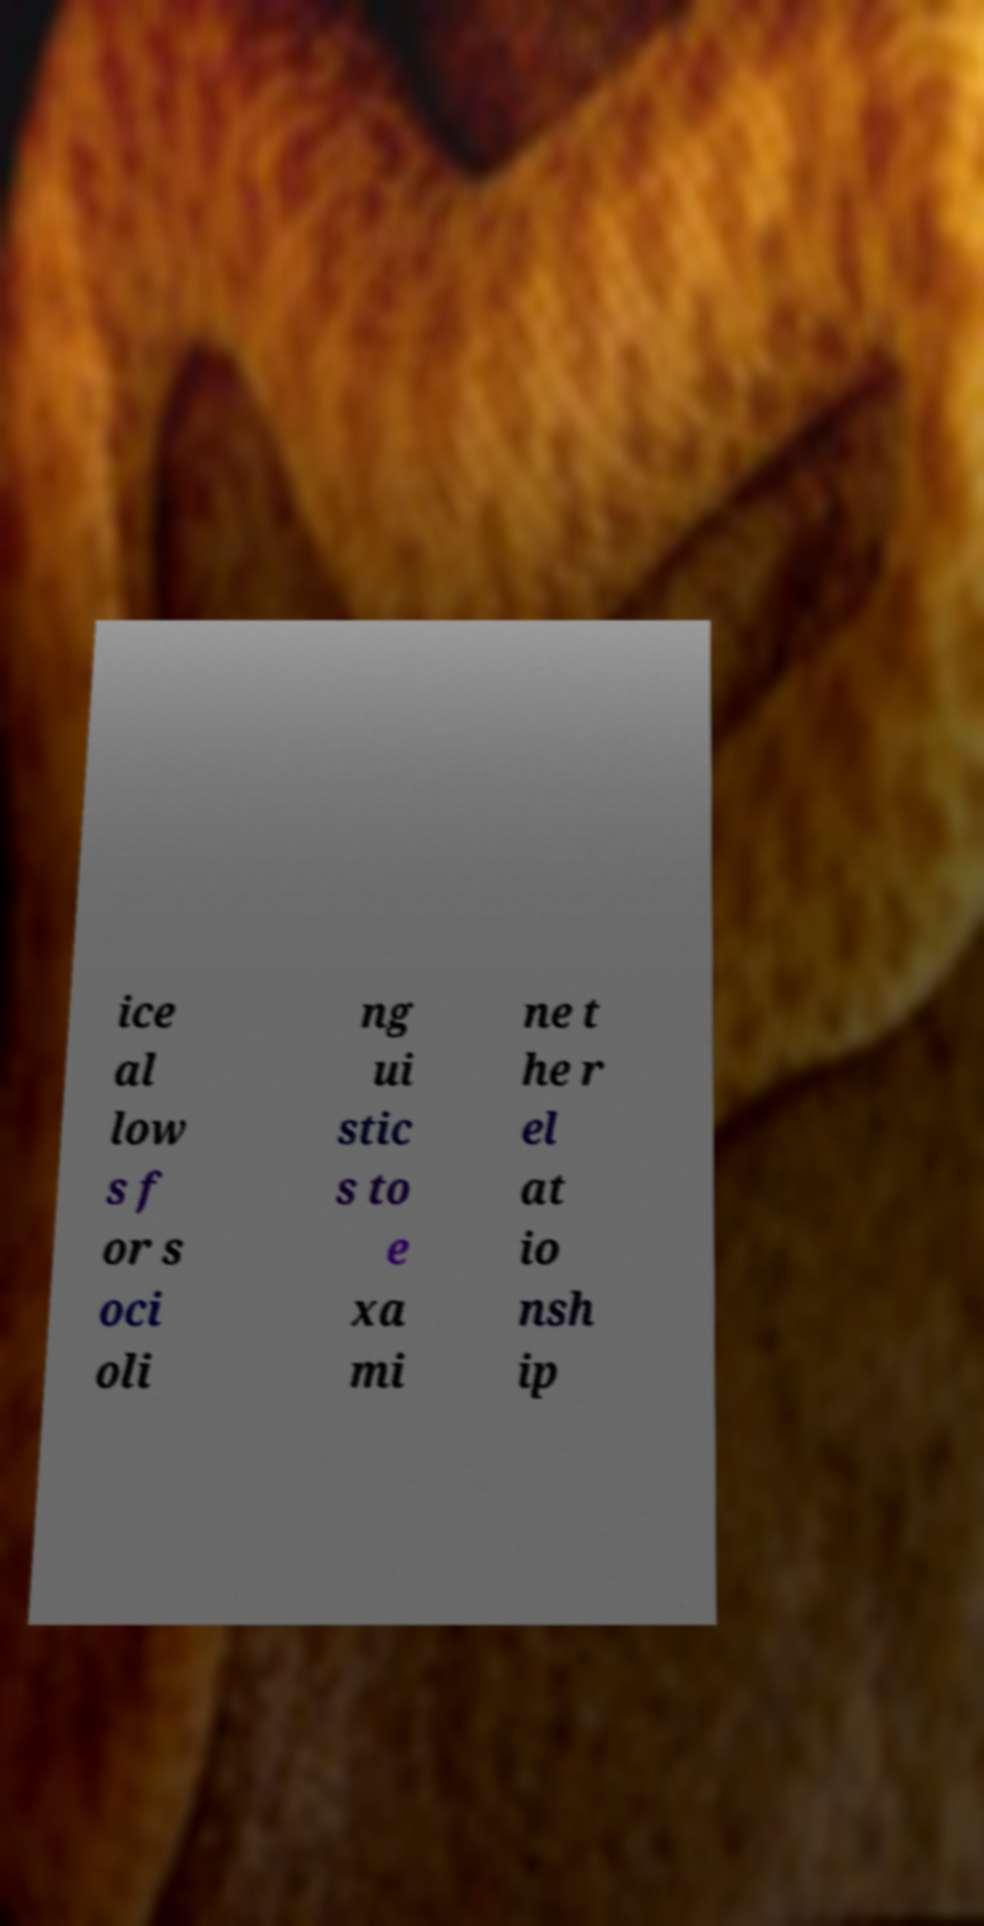There's text embedded in this image that I need extracted. Can you transcribe it verbatim? ice al low s f or s oci oli ng ui stic s to e xa mi ne t he r el at io nsh ip 